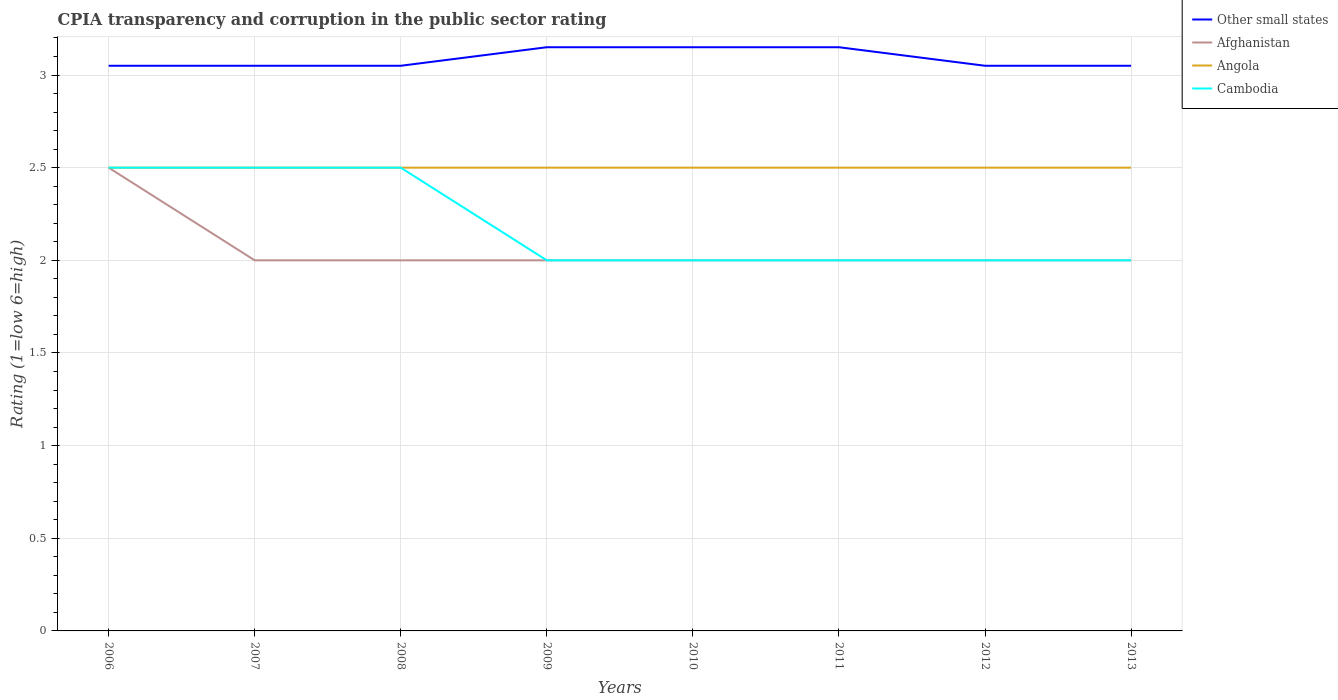How many different coloured lines are there?
Provide a succinct answer. 4. Is the number of lines equal to the number of legend labels?
Give a very brief answer. Yes. What is the total CPIA rating in Cambodia in the graph?
Ensure brevity in your answer.  0.5. What is the difference between the highest and the second highest CPIA rating in Angola?
Ensure brevity in your answer.  0. How many years are there in the graph?
Keep it short and to the point. 8. Does the graph contain any zero values?
Your answer should be very brief. No. Does the graph contain grids?
Make the answer very short. Yes. How many legend labels are there?
Offer a terse response. 4. How are the legend labels stacked?
Provide a succinct answer. Vertical. What is the title of the graph?
Your response must be concise. CPIA transparency and corruption in the public sector rating. Does "Gambia, The" appear as one of the legend labels in the graph?
Ensure brevity in your answer.  No. What is the Rating (1=low 6=high) of Other small states in 2006?
Provide a succinct answer. 3.05. What is the Rating (1=low 6=high) in Other small states in 2007?
Ensure brevity in your answer.  3.05. What is the Rating (1=low 6=high) in Afghanistan in 2007?
Offer a terse response. 2. What is the Rating (1=low 6=high) of Angola in 2007?
Ensure brevity in your answer.  2.5. What is the Rating (1=low 6=high) of Cambodia in 2007?
Make the answer very short. 2.5. What is the Rating (1=low 6=high) in Other small states in 2008?
Offer a terse response. 3.05. What is the Rating (1=low 6=high) in Afghanistan in 2008?
Ensure brevity in your answer.  2. What is the Rating (1=low 6=high) of Cambodia in 2008?
Make the answer very short. 2.5. What is the Rating (1=low 6=high) of Other small states in 2009?
Provide a short and direct response. 3.15. What is the Rating (1=low 6=high) of Afghanistan in 2009?
Make the answer very short. 2. What is the Rating (1=low 6=high) in Other small states in 2010?
Your response must be concise. 3.15. What is the Rating (1=low 6=high) of Afghanistan in 2010?
Offer a very short reply. 2. What is the Rating (1=low 6=high) in Angola in 2010?
Give a very brief answer. 2.5. What is the Rating (1=low 6=high) of Cambodia in 2010?
Provide a short and direct response. 2. What is the Rating (1=low 6=high) of Other small states in 2011?
Your response must be concise. 3.15. What is the Rating (1=low 6=high) in Other small states in 2012?
Offer a terse response. 3.05. What is the Rating (1=low 6=high) of Angola in 2012?
Provide a short and direct response. 2.5. What is the Rating (1=low 6=high) in Other small states in 2013?
Your answer should be very brief. 3.05. What is the Rating (1=low 6=high) in Afghanistan in 2013?
Provide a short and direct response. 2. What is the Rating (1=low 6=high) in Angola in 2013?
Provide a short and direct response. 2.5. Across all years, what is the maximum Rating (1=low 6=high) in Other small states?
Ensure brevity in your answer.  3.15. Across all years, what is the maximum Rating (1=low 6=high) of Afghanistan?
Keep it short and to the point. 2.5. Across all years, what is the maximum Rating (1=low 6=high) of Angola?
Give a very brief answer. 2.5. Across all years, what is the minimum Rating (1=low 6=high) of Other small states?
Ensure brevity in your answer.  3.05. Across all years, what is the minimum Rating (1=low 6=high) of Afghanistan?
Offer a terse response. 2. Across all years, what is the minimum Rating (1=low 6=high) in Cambodia?
Keep it short and to the point. 2. What is the total Rating (1=low 6=high) in Other small states in the graph?
Your answer should be very brief. 24.7. What is the total Rating (1=low 6=high) in Afghanistan in the graph?
Provide a short and direct response. 16.5. What is the total Rating (1=low 6=high) of Cambodia in the graph?
Offer a terse response. 17.5. What is the difference between the Rating (1=low 6=high) in Afghanistan in 2006 and that in 2007?
Offer a terse response. 0.5. What is the difference between the Rating (1=low 6=high) of Cambodia in 2006 and that in 2007?
Provide a succinct answer. 0. What is the difference between the Rating (1=low 6=high) of Angola in 2006 and that in 2008?
Offer a terse response. 0. What is the difference between the Rating (1=low 6=high) of Cambodia in 2006 and that in 2008?
Give a very brief answer. 0. What is the difference between the Rating (1=low 6=high) in Other small states in 2006 and that in 2009?
Offer a very short reply. -0.1. What is the difference between the Rating (1=low 6=high) of Angola in 2006 and that in 2009?
Offer a terse response. 0. What is the difference between the Rating (1=low 6=high) of Cambodia in 2006 and that in 2009?
Provide a short and direct response. 0.5. What is the difference between the Rating (1=low 6=high) in Afghanistan in 2006 and that in 2010?
Give a very brief answer. 0.5. What is the difference between the Rating (1=low 6=high) of Angola in 2006 and that in 2010?
Your answer should be very brief. 0. What is the difference between the Rating (1=low 6=high) in Cambodia in 2006 and that in 2010?
Make the answer very short. 0.5. What is the difference between the Rating (1=low 6=high) in Other small states in 2006 and that in 2011?
Give a very brief answer. -0.1. What is the difference between the Rating (1=low 6=high) of Angola in 2006 and that in 2011?
Provide a short and direct response. 0. What is the difference between the Rating (1=low 6=high) of Other small states in 2006 and that in 2012?
Offer a very short reply. 0. What is the difference between the Rating (1=low 6=high) in Afghanistan in 2006 and that in 2012?
Keep it short and to the point. 0.5. What is the difference between the Rating (1=low 6=high) of Angola in 2006 and that in 2012?
Make the answer very short. 0. What is the difference between the Rating (1=low 6=high) in Cambodia in 2006 and that in 2012?
Provide a succinct answer. 0.5. What is the difference between the Rating (1=low 6=high) of Other small states in 2006 and that in 2013?
Provide a short and direct response. 0. What is the difference between the Rating (1=low 6=high) in Afghanistan in 2006 and that in 2013?
Your response must be concise. 0.5. What is the difference between the Rating (1=low 6=high) in Angola in 2006 and that in 2013?
Provide a short and direct response. 0. What is the difference between the Rating (1=low 6=high) in Other small states in 2007 and that in 2009?
Ensure brevity in your answer.  -0.1. What is the difference between the Rating (1=low 6=high) of Afghanistan in 2007 and that in 2009?
Offer a terse response. 0. What is the difference between the Rating (1=low 6=high) of Angola in 2007 and that in 2009?
Your answer should be compact. 0. What is the difference between the Rating (1=low 6=high) of Angola in 2007 and that in 2010?
Give a very brief answer. 0. What is the difference between the Rating (1=low 6=high) in Cambodia in 2007 and that in 2010?
Make the answer very short. 0.5. What is the difference between the Rating (1=low 6=high) of Cambodia in 2007 and that in 2011?
Give a very brief answer. 0.5. What is the difference between the Rating (1=low 6=high) in Other small states in 2007 and that in 2012?
Provide a succinct answer. 0. What is the difference between the Rating (1=low 6=high) in Afghanistan in 2007 and that in 2013?
Ensure brevity in your answer.  0. What is the difference between the Rating (1=low 6=high) of Angola in 2007 and that in 2013?
Your answer should be compact. 0. What is the difference between the Rating (1=low 6=high) in Other small states in 2008 and that in 2009?
Provide a short and direct response. -0.1. What is the difference between the Rating (1=low 6=high) of Afghanistan in 2008 and that in 2009?
Provide a succinct answer. 0. What is the difference between the Rating (1=low 6=high) of Afghanistan in 2008 and that in 2010?
Offer a very short reply. 0. What is the difference between the Rating (1=low 6=high) in Afghanistan in 2008 and that in 2011?
Provide a succinct answer. 0. What is the difference between the Rating (1=low 6=high) of Cambodia in 2008 and that in 2011?
Your answer should be very brief. 0.5. What is the difference between the Rating (1=low 6=high) of Other small states in 2008 and that in 2012?
Give a very brief answer. 0. What is the difference between the Rating (1=low 6=high) of Angola in 2008 and that in 2012?
Your answer should be very brief. 0. What is the difference between the Rating (1=low 6=high) of Other small states in 2008 and that in 2013?
Ensure brevity in your answer.  0. What is the difference between the Rating (1=low 6=high) of Afghanistan in 2008 and that in 2013?
Make the answer very short. 0. What is the difference between the Rating (1=low 6=high) in Other small states in 2009 and that in 2010?
Your answer should be very brief. 0. What is the difference between the Rating (1=low 6=high) of Angola in 2009 and that in 2010?
Your answer should be compact. 0. What is the difference between the Rating (1=low 6=high) in Cambodia in 2009 and that in 2010?
Offer a terse response. 0. What is the difference between the Rating (1=low 6=high) of Other small states in 2009 and that in 2011?
Provide a succinct answer. 0. What is the difference between the Rating (1=low 6=high) in Angola in 2009 and that in 2011?
Provide a short and direct response. 0. What is the difference between the Rating (1=low 6=high) in Other small states in 2009 and that in 2012?
Your answer should be very brief. 0.1. What is the difference between the Rating (1=low 6=high) in Angola in 2009 and that in 2012?
Offer a very short reply. 0. What is the difference between the Rating (1=low 6=high) in Cambodia in 2009 and that in 2012?
Your answer should be very brief. 0. What is the difference between the Rating (1=low 6=high) in Other small states in 2009 and that in 2013?
Provide a short and direct response. 0.1. What is the difference between the Rating (1=low 6=high) of Afghanistan in 2009 and that in 2013?
Make the answer very short. 0. What is the difference between the Rating (1=low 6=high) of Cambodia in 2009 and that in 2013?
Keep it short and to the point. 0. What is the difference between the Rating (1=low 6=high) of Other small states in 2010 and that in 2011?
Give a very brief answer. 0. What is the difference between the Rating (1=low 6=high) of Afghanistan in 2010 and that in 2011?
Provide a succinct answer. 0. What is the difference between the Rating (1=low 6=high) in Afghanistan in 2010 and that in 2012?
Make the answer very short. 0. What is the difference between the Rating (1=low 6=high) of Angola in 2010 and that in 2012?
Offer a very short reply. 0. What is the difference between the Rating (1=low 6=high) in Other small states in 2011 and that in 2012?
Provide a succinct answer. 0.1. What is the difference between the Rating (1=low 6=high) in Afghanistan in 2011 and that in 2012?
Your answer should be very brief. 0. What is the difference between the Rating (1=low 6=high) of Afghanistan in 2011 and that in 2013?
Your answer should be very brief. 0. What is the difference between the Rating (1=low 6=high) of Other small states in 2012 and that in 2013?
Provide a succinct answer. 0. What is the difference between the Rating (1=low 6=high) of Angola in 2012 and that in 2013?
Ensure brevity in your answer.  0. What is the difference between the Rating (1=low 6=high) of Cambodia in 2012 and that in 2013?
Make the answer very short. 0. What is the difference between the Rating (1=low 6=high) in Other small states in 2006 and the Rating (1=low 6=high) in Angola in 2007?
Your response must be concise. 0.55. What is the difference between the Rating (1=low 6=high) in Other small states in 2006 and the Rating (1=low 6=high) in Cambodia in 2007?
Offer a very short reply. 0.55. What is the difference between the Rating (1=low 6=high) in Afghanistan in 2006 and the Rating (1=low 6=high) in Angola in 2007?
Your answer should be very brief. 0. What is the difference between the Rating (1=low 6=high) in Other small states in 2006 and the Rating (1=low 6=high) in Angola in 2008?
Give a very brief answer. 0.55. What is the difference between the Rating (1=low 6=high) of Other small states in 2006 and the Rating (1=low 6=high) of Cambodia in 2008?
Keep it short and to the point. 0.55. What is the difference between the Rating (1=low 6=high) of Angola in 2006 and the Rating (1=low 6=high) of Cambodia in 2008?
Ensure brevity in your answer.  0. What is the difference between the Rating (1=low 6=high) in Other small states in 2006 and the Rating (1=low 6=high) in Angola in 2009?
Provide a short and direct response. 0.55. What is the difference between the Rating (1=low 6=high) in Afghanistan in 2006 and the Rating (1=low 6=high) in Angola in 2009?
Your response must be concise. 0. What is the difference between the Rating (1=low 6=high) of Afghanistan in 2006 and the Rating (1=low 6=high) of Cambodia in 2009?
Offer a very short reply. 0.5. What is the difference between the Rating (1=low 6=high) in Other small states in 2006 and the Rating (1=low 6=high) in Afghanistan in 2010?
Your answer should be very brief. 1.05. What is the difference between the Rating (1=low 6=high) of Other small states in 2006 and the Rating (1=low 6=high) of Angola in 2010?
Your answer should be very brief. 0.55. What is the difference between the Rating (1=low 6=high) of Afghanistan in 2006 and the Rating (1=low 6=high) of Angola in 2010?
Keep it short and to the point. 0. What is the difference between the Rating (1=low 6=high) of Afghanistan in 2006 and the Rating (1=low 6=high) of Cambodia in 2010?
Keep it short and to the point. 0.5. What is the difference between the Rating (1=low 6=high) in Other small states in 2006 and the Rating (1=low 6=high) in Afghanistan in 2011?
Your response must be concise. 1.05. What is the difference between the Rating (1=low 6=high) of Other small states in 2006 and the Rating (1=low 6=high) of Angola in 2011?
Keep it short and to the point. 0.55. What is the difference between the Rating (1=low 6=high) of Other small states in 2006 and the Rating (1=low 6=high) of Cambodia in 2011?
Provide a succinct answer. 1.05. What is the difference between the Rating (1=low 6=high) of Afghanistan in 2006 and the Rating (1=low 6=high) of Angola in 2011?
Provide a succinct answer. 0. What is the difference between the Rating (1=low 6=high) of Angola in 2006 and the Rating (1=low 6=high) of Cambodia in 2011?
Make the answer very short. 0.5. What is the difference between the Rating (1=low 6=high) of Other small states in 2006 and the Rating (1=low 6=high) of Afghanistan in 2012?
Your answer should be very brief. 1.05. What is the difference between the Rating (1=low 6=high) in Other small states in 2006 and the Rating (1=low 6=high) in Angola in 2012?
Give a very brief answer. 0.55. What is the difference between the Rating (1=low 6=high) in Other small states in 2006 and the Rating (1=low 6=high) in Cambodia in 2012?
Offer a very short reply. 1.05. What is the difference between the Rating (1=low 6=high) of Other small states in 2006 and the Rating (1=low 6=high) of Angola in 2013?
Give a very brief answer. 0.55. What is the difference between the Rating (1=low 6=high) in Afghanistan in 2006 and the Rating (1=low 6=high) in Cambodia in 2013?
Offer a terse response. 0.5. What is the difference between the Rating (1=low 6=high) of Angola in 2006 and the Rating (1=low 6=high) of Cambodia in 2013?
Keep it short and to the point. 0.5. What is the difference between the Rating (1=low 6=high) in Other small states in 2007 and the Rating (1=low 6=high) in Afghanistan in 2008?
Offer a very short reply. 1.05. What is the difference between the Rating (1=low 6=high) in Other small states in 2007 and the Rating (1=low 6=high) in Angola in 2008?
Ensure brevity in your answer.  0.55. What is the difference between the Rating (1=low 6=high) in Other small states in 2007 and the Rating (1=low 6=high) in Cambodia in 2008?
Keep it short and to the point. 0.55. What is the difference between the Rating (1=low 6=high) in Afghanistan in 2007 and the Rating (1=low 6=high) in Cambodia in 2008?
Give a very brief answer. -0.5. What is the difference between the Rating (1=low 6=high) of Angola in 2007 and the Rating (1=low 6=high) of Cambodia in 2008?
Give a very brief answer. 0. What is the difference between the Rating (1=low 6=high) of Other small states in 2007 and the Rating (1=low 6=high) of Angola in 2009?
Keep it short and to the point. 0.55. What is the difference between the Rating (1=low 6=high) in Afghanistan in 2007 and the Rating (1=low 6=high) in Cambodia in 2009?
Offer a terse response. 0. What is the difference between the Rating (1=low 6=high) in Other small states in 2007 and the Rating (1=low 6=high) in Afghanistan in 2010?
Your answer should be very brief. 1.05. What is the difference between the Rating (1=low 6=high) in Other small states in 2007 and the Rating (1=low 6=high) in Angola in 2010?
Your response must be concise. 0.55. What is the difference between the Rating (1=low 6=high) of Other small states in 2007 and the Rating (1=low 6=high) of Cambodia in 2010?
Ensure brevity in your answer.  1.05. What is the difference between the Rating (1=low 6=high) of Afghanistan in 2007 and the Rating (1=low 6=high) of Angola in 2010?
Make the answer very short. -0.5. What is the difference between the Rating (1=low 6=high) in Angola in 2007 and the Rating (1=low 6=high) in Cambodia in 2010?
Keep it short and to the point. 0.5. What is the difference between the Rating (1=low 6=high) of Other small states in 2007 and the Rating (1=low 6=high) of Afghanistan in 2011?
Give a very brief answer. 1.05. What is the difference between the Rating (1=low 6=high) in Other small states in 2007 and the Rating (1=low 6=high) in Angola in 2011?
Your answer should be very brief. 0.55. What is the difference between the Rating (1=low 6=high) of Other small states in 2007 and the Rating (1=low 6=high) of Cambodia in 2011?
Offer a terse response. 1.05. What is the difference between the Rating (1=low 6=high) in Afghanistan in 2007 and the Rating (1=low 6=high) in Angola in 2011?
Offer a very short reply. -0.5. What is the difference between the Rating (1=low 6=high) in Afghanistan in 2007 and the Rating (1=low 6=high) in Cambodia in 2011?
Your answer should be very brief. 0. What is the difference between the Rating (1=low 6=high) in Other small states in 2007 and the Rating (1=low 6=high) in Angola in 2012?
Offer a terse response. 0.55. What is the difference between the Rating (1=low 6=high) of Other small states in 2007 and the Rating (1=low 6=high) of Cambodia in 2012?
Your answer should be very brief. 1.05. What is the difference between the Rating (1=low 6=high) in Angola in 2007 and the Rating (1=low 6=high) in Cambodia in 2012?
Your answer should be compact. 0.5. What is the difference between the Rating (1=low 6=high) of Other small states in 2007 and the Rating (1=low 6=high) of Afghanistan in 2013?
Provide a succinct answer. 1.05. What is the difference between the Rating (1=low 6=high) in Other small states in 2007 and the Rating (1=low 6=high) in Angola in 2013?
Provide a succinct answer. 0.55. What is the difference between the Rating (1=low 6=high) in Other small states in 2007 and the Rating (1=low 6=high) in Cambodia in 2013?
Offer a very short reply. 1.05. What is the difference between the Rating (1=low 6=high) of Afghanistan in 2007 and the Rating (1=low 6=high) of Angola in 2013?
Your response must be concise. -0.5. What is the difference between the Rating (1=low 6=high) of Afghanistan in 2007 and the Rating (1=low 6=high) of Cambodia in 2013?
Provide a short and direct response. 0. What is the difference between the Rating (1=low 6=high) of Other small states in 2008 and the Rating (1=low 6=high) of Afghanistan in 2009?
Your response must be concise. 1.05. What is the difference between the Rating (1=low 6=high) in Other small states in 2008 and the Rating (1=low 6=high) in Angola in 2009?
Your answer should be compact. 0.55. What is the difference between the Rating (1=low 6=high) of Afghanistan in 2008 and the Rating (1=low 6=high) of Angola in 2009?
Your answer should be compact. -0.5. What is the difference between the Rating (1=low 6=high) of Afghanistan in 2008 and the Rating (1=low 6=high) of Cambodia in 2009?
Your answer should be very brief. 0. What is the difference between the Rating (1=low 6=high) of Angola in 2008 and the Rating (1=low 6=high) of Cambodia in 2009?
Your answer should be very brief. 0.5. What is the difference between the Rating (1=low 6=high) of Other small states in 2008 and the Rating (1=low 6=high) of Afghanistan in 2010?
Provide a short and direct response. 1.05. What is the difference between the Rating (1=low 6=high) in Other small states in 2008 and the Rating (1=low 6=high) in Angola in 2010?
Offer a very short reply. 0.55. What is the difference between the Rating (1=low 6=high) in Afghanistan in 2008 and the Rating (1=low 6=high) in Angola in 2010?
Your response must be concise. -0.5. What is the difference between the Rating (1=low 6=high) of Afghanistan in 2008 and the Rating (1=low 6=high) of Cambodia in 2010?
Keep it short and to the point. 0. What is the difference between the Rating (1=low 6=high) of Angola in 2008 and the Rating (1=low 6=high) of Cambodia in 2010?
Keep it short and to the point. 0.5. What is the difference between the Rating (1=low 6=high) in Other small states in 2008 and the Rating (1=low 6=high) in Angola in 2011?
Make the answer very short. 0.55. What is the difference between the Rating (1=low 6=high) in Afghanistan in 2008 and the Rating (1=low 6=high) in Angola in 2011?
Provide a succinct answer. -0.5. What is the difference between the Rating (1=low 6=high) in Afghanistan in 2008 and the Rating (1=low 6=high) in Cambodia in 2011?
Provide a succinct answer. 0. What is the difference between the Rating (1=low 6=high) in Other small states in 2008 and the Rating (1=low 6=high) in Angola in 2012?
Ensure brevity in your answer.  0.55. What is the difference between the Rating (1=low 6=high) of Afghanistan in 2008 and the Rating (1=low 6=high) of Angola in 2012?
Provide a short and direct response. -0.5. What is the difference between the Rating (1=low 6=high) in Angola in 2008 and the Rating (1=low 6=high) in Cambodia in 2012?
Offer a terse response. 0.5. What is the difference between the Rating (1=low 6=high) of Other small states in 2008 and the Rating (1=low 6=high) of Angola in 2013?
Provide a succinct answer. 0.55. What is the difference between the Rating (1=low 6=high) of Afghanistan in 2008 and the Rating (1=low 6=high) of Angola in 2013?
Keep it short and to the point. -0.5. What is the difference between the Rating (1=low 6=high) of Other small states in 2009 and the Rating (1=low 6=high) of Afghanistan in 2010?
Ensure brevity in your answer.  1.15. What is the difference between the Rating (1=low 6=high) of Other small states in 2009 and the Rating (1=low 6=high) of Angola in 2010?
Your response must be concise. 0.65. What is the difference between the Rating (1=low 6=high) in Other small states in 2009 and the Rating (1=low 6=high) in Cambodia in 2010?
Your answer should be very brief. 1.15. What is the difference between the Rating (1=low 6=high) in Afghanistan in 2009 and the Rating (1=low 6=high) in Angola in 2010?
Your answer should be compact. -0.5. What is the difference between the Rating (1=low 6=high) of Angola in 2009 and the Rating (1=low 6=high) of Cambodia in 2010?
Make the answer very short. 0.5. What is the difference between the Rating (1=low 6=high) in Other small states in 2009 and the Rating (1=low 6=high) in Afghanistan in 2011?
Keep it short and to the point. 1.15. What is the difference between the Rating (1=low 6=high) in Other small states in 2009 and the Rating (1=low 6=high) in Angola in 2011?
Offer a very short reply. 0.65. What is the difference between the Rating (1=low 6=high) of Other small states in 2009 and the Rating (1=low 6=high) of Cambodia in 2011?
Provide a short and direct response. 1.15. What is the difference between the Rating (1=low 6=high) of Afghanistan in 2009 and the Rating (1=low 6=high) of Angola in 2011?
Give a very brief answer. -0.5. What is the difference between the Rating (1=low 6=high) in Afghanistan in 2009 and the Rating (1=low 6=high) in Cambodia in 2011?
Make the answer very short. 0. What is the difference between the Rating (1=low 6=high) of Angola in 2009 and the Rating (1=low 6=high) of Cambodia in 2011?
Ensure brevity in your answer.  0.5. What is the difference between the Rating (1=low 6=high) of Other small states in 2009 and the Rating (1=low 6=high) of Afghanistan in 2012?
Your answer should be very brief. 1.15. What is the difference between the Rating (1=low 6=high) of Other small states in 2009 and the Rating (1=low 6=high) of Angola in 2012?
Give a very brief answer. 0.65. What is the difference between the Rating (1=low 6=high) in Other small states in 2009 and the Rating (1=low 6=high) in Cambodia in 2012?
Your response must be concise. 1.15. What is the difference between the Rating (1=low 6=high) of Afghanistan in 2009 and the Rating (1=low 6=high) of Angola in 2012?
Give a very brief answer. -0.5. What is the difference between the Rating (1=low 6=high) in Other small states in 2009 and the Rating (1=low 6=high) in Afghanistan in 2013?
Keep it short and to the point. 1.15. What is the difference between the Rating (1=low 6=high) of Other small states in 2009 and the Rating (1=low 6=high) of Angola in 2013?
Ensure brevity in your answer.  0.65. What is the difference between the Rating (1=low 6=high) of Other small states in 2009 and the Rating (1=low 6=high) of Cambodia in 2013?
Keep it short and to the point. 1.15. What is the difference between the Rating (1=low 6=high) of Afghanistan in 2009 and the Rating (1=low 6=high) of Angola in 2013?
Ensure brevity in your answer.  -0.5. What is the difference between the Rating (1=low 6=high) in Afghanistan in 2009 and the Rating (1=low 6=high) in Cambodia in 2013?
Offer a terse response. 0. What is the difference between the Rating (1=low 6=high) in Angola in 2009 and the Rating (1=low 6=high) in Cambodia in 2013?
Provide a succinct answer. 0.5. What is the difference between the Rating (1=low 6=high) of Other small states in 2010 and the Rating (1=low 6=high) of Afghanistan in 2011?
Your response must be concise. 1.15. What is the difference between the Rating (1=low 6=high) of Other small states in 2010 and the Rating (1=low 6=high) of Angola in 2011?
Your response must be concise. 0.65. What is the difference between the Rating (1=low 6=high) in Other small states in 2010 and the Rating (1=low 6=high) in Cambodia in 2011?
Your response must be concise. 1.15. What is the difference between the Rating (1=low 6=high) of Afghanistan in 2010 and the Rating (1=low 6=high) of Angola in 2011?
Keep it short and to the point. -0.5. What is the difference between the Rating (1=low 6=high) of Angola in 2010 and the Rating (1=low 6=high) of Cambodia in 2011?
Offer a very short reply. 0.5. What is the difference between the Rating (1=low 6=high) of Other small states in 2010 and the Rating (1=low 6=high) of Afghanistan in 2012?
Your response must be concise. 1.15. What is the difference between the Rating (1=low 6=high) of Other small states in 2010 and the Rating (1=low 6=high) of Angola in 2012?
Give a very brief answer. 0.65. What is the difference between the Rating (1=low 6=high) of Other small states in 2010 and the Rating (1=low 6=high) of Cambodia in 2012?
Offer a terse response. 1.15. What is the difference between the Rating (1=low 6=high) of Other small states in 2010 and the Rating (1=low 6=high) of Afghanistan in 2013?
Make the answer very short. 1.15. What is the difference between the Rating (1=low 6=high) in Other small states in 2010 and the Rating (1=low 6=high) in Angola in 2013?
Provide a short and direct response. 0.65. What is the difference between the Rating (1=low 6=high) in Other small states in 2010 and the Rating (1=low 6=high) in Cambodia in 2013?
Your response must be concise. 1.15. What is the difference between the Rating (1=low 6=high) of Afghanistan in 2010 and the Rating (1=low 6=high) of Angola in 2013?
Your response must be concise. -0.5. What is the difference between the Rating (1=low 6=high) of Afghanistan in 2010 and the Rating (1=low 6=high) of Cambodia in 2013?
Provide a short and direct response. 0. What is the difference between the Rating (1=low 6=high) of Angola in 2010 and the Rating (1=low 6=high) of Cambodia in 2013?
Ensure brevity in your answer.  0.5. What is the difference between the Rating (1=low 6=high) in Other small states in 2011 and the Rating (1=low 6=high) in Afghanistan in 2012?
Provide a succinct answer. 1.15. What is the difference between the Rating (1=low 6=high) in Other small states in 2011 and the Rating (1=low 6=high) in Angola in 2012?
Offer a very short reply. 0.65. What is the difference between the Rating (1=low 6=high) of Other small states in 2011 and the Rating (1=low 6=high) of Cambodia in 2012?
Your response must be concise. 1.15. What is the difference between the Rating (1=low 6=high) of Afghanistan in 2011 and the Rating (1=low 6=high) of Cambodia in 2012?
Make the answer very short. 0. What is the difference between the Rating (1=low 6=high) in Angola in 2011 and the Rating (1=low 6=high) in Cambodia in 2012?
Provide a short and direct response. 0.5. What is the difference between the Rating (1=low 6=high) in Other small states in 2011 and the Rating (1=low 6=high) in Afghanistan in 2013?
Give a very brief answer. 1.15. What is the difference between the Rating (1=low 6=high) of Other small states in 2011 and the Rating (1=low 6=high) of Angola in 2013?
Offer a terse response. 0.65. What is the difference between the Rating (1=low 6=high) of Other small states in 2011 and the Rating (1=low 6=high) of Cambodia in 2013?
Make the answer very short. 1.15. What is the difference between the Rating (1=low 6=high) of Afghanistan in 2011 and the Rating (1=low 6=high) of Cambodia in 2013?
Make the answer very short. 0. What is the difference between the Rating (1=low 6=high) in Angola in 2011 and the Rating (1=low 6=high) in Cambodia in 2013?
Keep it short and to the point. 0.5. What is the difference between the Rating (1=low 6=high) of Other small states in 2012 and the Rating (1=low 6=high) of Angola in 2013?
Make the answer very short. 0.55. What is the difference between the Rating (1=low 6=high) in Other small states in 2012 and the Rating (1=low 6=high) in Cambodia in 2013?
Your answer should be very brief. 1.05. What is the difference between the Rating (1=low 6=high) of Afghanistan in 2012 and the Rating (1=low 6=high) of Angola in 2013?
Your answer should be very brief. -0.5. What is the difference between the Rating (1=low 6=high) of Afghanistan in 2012 and the Rating (1=low 6=high) of Cambodia in 2013?
Keep it short and to the point. 0. What is the difference between the Rating (1=low 6=high) of Angola in 2012 and the Rating (1=low 6=high) of Cambodia in 2013?
Your answer should be very brief. 0.5. What is the average Rating (1=low 6=high) in Other small states per year?
Keep it short and to the point. 3.09. What is the average Rating (1=low 6=high) of Afghanistan per year?
Offer a very short reply. 2.06. What is the average Rating (1=low 6=high) of Cambodia per year?
Offer a very short reply. 2.19. In the year 2006, what is the difference between the Rating (1=low 6=high) in Other small states and Rating (1=low 6=high) in Afghanistan?
Keep it short and to the point. 0.55. In the year 2006, what is the difference between the Rating (1=low 6=high) in Other small states and Rating (1=low 6=high) in Angola?
Make the answer very short. 0.55. In the year 2006, what is the difference between the Rating (1=low 6=high) of Other small states and Rating (1=low 6=high) of Cambodia?
Provide a succinct answer. 0.55. In the year 2006, what is the difference between the Rating (1=low 6=high) of Afghanistan and Rating (1=low 6=high) of Angola?
Keep it short and to the point. 0. In the year 2006, what is the difference between the Rating (1=low 6=high) in Angola and Rating (1=low 6=high) in Cambodia?
Ensure brevity in your answer.  0. In the year 2007, what is the difference between the Rating (1=low 6=high) in Other small states and Rating (1=low 6=high) in Angola?
Offer a very short reply. 0.55. In the year 2007, what is the difference between the Rating (1=low 6=high) of Other small states and Rating (1=low 6=high) of Cambodia?
Ensure brevity in your answer.  0.55. In the year 2007, what is the difference between the Rating (1=low 6=high) of Afghanistan and Rating (1=low 6=high) of Angola?
Your answer should be compact. -0.5. In the year 2007, what is the difference between the Rating (1=low 6=high) of Afghanistan and Rating (1=low 6=high) of Cambodia?
Make the answer very short. -0.5. In the year 2008, what is the difference between the Rating (1=low 6=high) in Other small states and Rating (1=low 6=high) in Angola?
Your answer should be compact. 0.55. In the year 2008, what is the difference between the Rating (1=low 6=high) in Other small states and Rating (1=low 6=high) in Cambodia?
Provide a short and direct response. 0.55. In the year 2008, what is the difference between the Rating (1=low 6=high) of Afghanistan and Rating (1=low 6=high) of Angola?
Your response must be concise. -0.5. In the year 2009, what is the difference between the Rating (1=low 6=high) of Other small states and Rating (1=low 6=high) of Afghanistan?
Your response must be concise. 1.15. In the year 2009, what is the difference between the Rating (1=low 6=high) in Other small states and Rating (1=low 6=high) in Angola?
Your answer should be very brief. 0.65. In the year 2009, what is the difference between the Rating (1=low 6=high) in Other small states and Rating (1=low 6=high) in Cambodia?
Keep it short and to the point. 1.15. In the year 2009, what is the difference between the Rating (1=low 6=high) of Afghanistan and Rating (1=low 6=high) of Angola?
Offer a very short reply. -0.5. In the year 2009, what is the difference between the Rating (1=low 6=high) in Afghanistan and Rating (1=low 6=high) in Cambodia?
Keep it short and to the point. 0. In the year 2010, what is the difference between the Rating (1=low 6=high) in Other small states and Rating (1=low 6=high) in Afghanistan?
Your response must be concise. 1.15. In the year 2010, what is the difference between the Rating (1=low 6=high) in Other small states and Rating (1=low 6=high) in Angola?
Offer a terse response. 0.65. In the year 2010, what is the difference between the Rating (1=low 6=high) in Other small states and Rating (1=low 6=high) in Cambodia?
Make the answer very short. 1.15. In the year 2010, what is the difference between the Rating (1=low 6=high) in Afghanistan and Rating (1=low 6=high) in Angola?
Provide a short and direct response. -0.5. In the year 2010, what is the difference between the Rating (1=low 6=high) in Afghanistan and Rating (1=low 6=high) in Cambodia?
Your answer should be compact. 0. In the year 2011, what is the difference between the Rating (1=low 6=high) in Other small states and Rating (1=low 6=high) in Afghanistan?
Offer a terse response. 1.15. In the year 2011, what is the difference between the Rating (1=low 6=high) in Other small states and Rating (1=low 6=high) in Angola?
Keep it short and to the point. 0.65. In the year 2011, what is the difference between the Rating (1=low 6=high) in Other small states and Rating (1=low 6=high) in Cambodia?
Your response must be concise. 1.15. In the year 2011, what is the difference between the Rating (1=low 6=high) in Afghanistan and Rating (1=low 6=high) in Angola?
Provide a succinct answer. -0.5. In the year 2011, what is the difference between the Rating (1=low 6=high) of Angola and Rating (1=low 6=high) of Cambodia?
Keep it short and to the point. 0.5. In the year 2012, what is the difference between the Rating (1=low 6=high) in Other small states and Rating (1=low 6=high) in Afghanistan?
Offer a very short reply. 1.05. In the year 2012, what is the difference between the Rating (1=low 6=high) of Other small states and Rating (1=low 6=high) of Angola?
Provide a short and direct response. 0.55. In the year 2012, what is the difference between the Rating (1=low 6=high) of Afghanistan and Rating (1=low 6=high) of Cambodia?
Provide a short and direct response. 0. In the year 2013, what is the difference between the Rating (1=low 6=high) in Other small states and Rating (1=low 6=high) in Angola?
Your response must be concise. 0.55. In the year 2013, what is the difference between the Rating (1=low 6=high) in Afghanistan and Rating (1=low 6=high) in Angola?
Provide a succinct answer. -0.5. In the year 2013, what is the difference between the Rating (1=low 6=high) in Afghanistan and Rating (1=low 6=high) in Cambodia?
Give a very brief answer. 0. In the year 2013, what is the difference between the Rating (1=low 6=high) in Angola and Rating (1=low 6=high) in Cambodia?
Your answer should be very brief. 0.5. What is the ratio of the Rating (1=low 6=high) in Other small states in 2006 to that in 2007?
Your answer should be compact. 1. What is the ratio of the Rating (1=low 6=high) in Angola in 2006 to that in 2007?
Offer a very short reply. 1. What is the ratio of the Rating (1=low 6=high) in Cambodia in 2006 to that in 2007?
Your answer should be compact. 1. What is the ratio of the Rating (1=low 6=high) in Angola in 2006 to that in 2008?
Keep it short and to the point. 1. What is the ratio of the Rating (1=low 6=high) in Cambodia in 2006 to that in 2008?
Your response must be concise. 1. What is the ratio of the Rating (1=low 6=high) in Other small states in 2006 to that in 2009?
Your response must be concise. 0.97. What is the ratio of the Rating (1=low 6=high) in Angola in 2006 to that in 2009?
Keep it short and to the point. 1. What is the ratio of the Rating (1=low 6=high) of Cambodia in 2006 to that in 2009?
Your answer should be compact. 1.25. What is the ratio of the Rating (1=low 6=high) of Other small states in 2006 to that in 2010?
Keep it short and to the point. 0.97. What is the ratio of the Rating (1=low 6=high) in Angola in 2006 to that in 2010?
Ensure brevity in your answer.  1. What is the ratio of the Rating (1=low 6=high) of Other small states in 2006 to that in 2011?
Your answer should be very brief. 0.97. What is the ratio of the Rating (1=low 6=high) of Angola in 2006 to that in 2011?
Offer a terse response. 1. What is the ratio of the Rating (1=low 6=high) of Afghanistan in 2006 to that in 2012?
Keep it short and to the point. 1.25. What is the ratio of the Rating (1=low 6=high) of Cambodia in 2006 to that in 2012?
Provide a short and direct response. 1.25. What is the ratio of the Rating (1=low 6=high) in Afghanistan in 2007 to that in 2008?
Your answer should be compact. 1. What is the ratio of the Rating (1=low 6=high) of Cambodia in 2007 to that in 2008?
Provide a short and direct response. 1. What is the ratio of the Rating (1=low 6=high) of Other small states in 2007 to that in 2009?
Provide a short and direct response. 0.97. What is the ratio of the Rating (1=low 6=high) in Angola in 2007 to that in 2009?
Provide a short and direct response. 1. What is the ratio of the Rating (1=low 6=high) of Other small states in 2007 to that in 2010?
Offer a very short reply. 0.97. What is the ratio of the Rating (1=low 6=high) of Angola in 2007 to that in 2010?
Offer a terse response. 1. What is the ratio of the Rating (1=low 6=high) in Cambodia in 2007 to that in 2010?
Provide a short and direct response. 1.25. What is the ratio of the Rating (1=low 6=high) of Other small states in 2007 to that in 2011?
Provide a short and direct response. 0.97. What is the ratio of the Rating (1=low 6=high) in Angola in 2007 to that in 2011?
Offer a very short reply. 1. What is the ratio of the Rating (1=low 6=high) in Other small states in 2007 to that in 2012?
Provide a short and direct response. 1. What is the ratio of the Rating (1=low 6=high) in Angola in 2007 to that in 2012?
Provide a succinct answer. 1. What is the ratio of the Rating (1=low 6=high) in Angola in 2007 to that in 2013?
Keep it short and to the point. 1. What is the ratio of the Rating (1=low 6=high) in Other small states in 2008 to that in 2009?
Offer a very short reply. 0.97. What is the ratio of the Rating (1=low 6=high) in Afghanistan in 2008 to that in 2009?
Ensure brevity in your answer.  1. What is the ratio of the Rating (1=low 6=high) of Angola in 2008 to that in 2009?
Ensure brevity in your answer.  1. What is the ratio of the Rating (1=low 6=high) of Cambodia in 2008 to that in 2009?
Offer a very short reply. 1.25. What is the ratio of the Rating (1=low 6=high) in Other small states in 2008 to that in 2010?
Ensure brevity in your answer.  0.97. What is the ratio of the Rating (1=low 6=high) in Angola in 2008 to that in 2010?
Give a very brief answer. 1. What is the ratio of the Rating (1=low 6=high) of Other small states in 2008 to that in 2011?
Provide a succinct answer. 0.97. What is the ratio of the Rating (1=low 6=high) of Afghanistan in 2008 to that in 2011?
Give a very brief answer. 1. What is the ratio of the Rating (1=low 6=high) of Angola in 2008 to that in 2011?
Offer a terse response. 1. What is the ratio of the Rating (1=low 6=high) of Other small states in 2008 to that in 2012?
Your response must be concise. 1. What is the ratio of the Rating (1=low 6=high) in Afghanistan in 2008 to that in 2012?
Your answer should be compact. 1. What is the ratio of the Rating (1=low 6=high) of Afghanistan in 2008 to that in 2013?
Your response must be concise. 1. What is the ratio of the Rating (1=low 6=high) of Cambodia in 2008 to that in 2013?
Provide a succinct answer. 1.25. What is the ratio of the Rating (1=low 6=high) in Afghanistan in 2009 to that in 2010?
Your response must be concise. 1. What is the ratio of the Rating (1=low 6=high) of Angola in 2009 to that in 2010?
Your answer should be very brief. 1. What is the ratio of the Rating (1=low 6=high) of Afghanistan in 2009 to that in 2011?
Your response must be concise. 1. What is the ratio of the Rating (1=low 6=high) of Angola in 2009 to that in 2011?
Your answer should be compact. 1. What is the ratio of the Rating (1=low 6=high) of Cambodia in 2009 to that in 2011?
Make the answer very short. 1. What is the ratio of the Rating (1=low 6=high) in Other small states in 2009 to that in 2012?
Give a very brief answer. 1.03. What is the ratio of the Rating (1=low 6=high) in Afghanistan in 2009 to that in 2012?
Your response must be concise. 1. What is the ratio of the Rating (1=low 6=high) in Cambodia in 2009 to that in 2012?
Make the answer very short. 1. What is the ratio of the Rating (1=low 6=high) of Other small states in 2009 to that in 2013?
Offer a very short reply. 1.03. What is the ratio of the Rating (1=low 6=high) of Angola in 2009 to that in 2013?
Give a very brief answer. 1. What is the ratio of the Rating (1=low 6=high) of Afghanistan in 2010 to that in 2011?
Give a very brief answer. 1. What is the ratio of the Rating (1=low 6=high) in Other small states in 2010 to that in 2012?
Keep it short and to the point. 1.03. What is the ratio of the Rating (1=low 6=high) in Afghanistan in 2010 to that in 2012?
Provide a succinct answer. 1. What is the ratio of the Rating (1=low 6=high) in Angola in 2010 to that in 2012?
Offer a very short reply. 1. What is the ratio of the Rating (1=low 6=high) of Other small states in 2010 to that in 2013?
Offer a very short reply. 1.03. What is the ratio of the Rating (1=low 6=high) in Afghanistan in 2010 to that in 2013?
Your answer should be compact. 1. What is the ratio of the Rating (1=low 6=high) of Other small states in 2011 to that in 2012?
Provide a short and direct response. 1.03. What is the ratio of the Rating (1=low 6=high) in Angola in 2011 to that in 2012?
Your answer should be very brief. 1. What is the ratio of the Rating (1=low 6=high) in Cambodia in 2011 to that in 2012?
Ensure brevity in your answer.  1. What is the ratio of the Rating (1=low 6=high) in Other small states in 2011 to that in 2013?
Make the answer very short. 1.03. What is the ratio of the Rating (1=low 6=high) in Angola in 2011 to that in 2013?
Your answer should be compact. 1. What is the ratio of the Rating (1=low 6=high) of Other small states in 2012 to that in 2013?
Keep it short and to the point. 1. What is the ratio of the Rating (1=low 6=high) in Afghanistan in 2012 to that in 2013?
Offer a terse response. 1. What is the ratio of the Rating (1=low 6=high) in Cambodia in 2012 to that in 2013?
Your answer should be very brief. 1. What is the difference between the highest and the second highest Rating (1=low 6=high) of Other small states?
Make the answer very short. 0. What is the difference between the highest and the second highest Rating (1=low 6=high) of Angola?
Give a very brief answer. 0. What is the difference between the highest and the lowest Rating (1=low 6=high) in Other small states?
Keep it short and to the point. 0.1. 